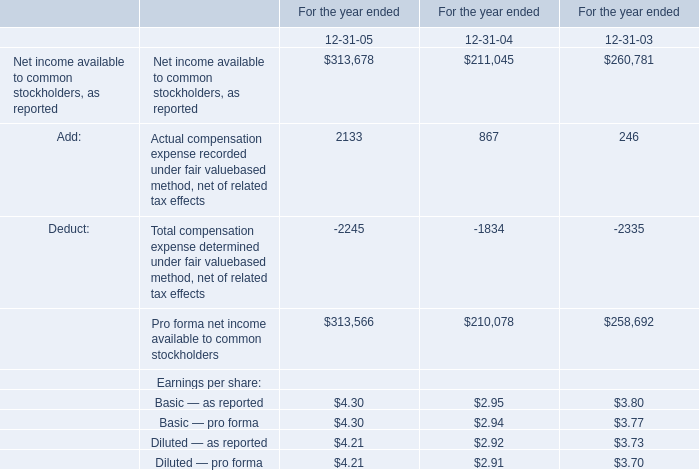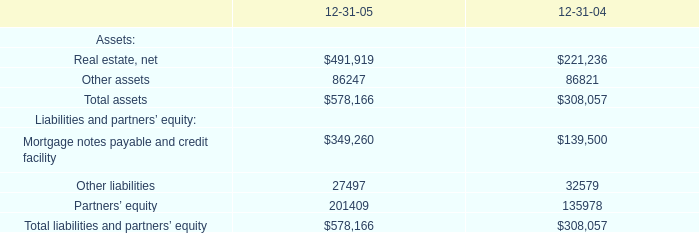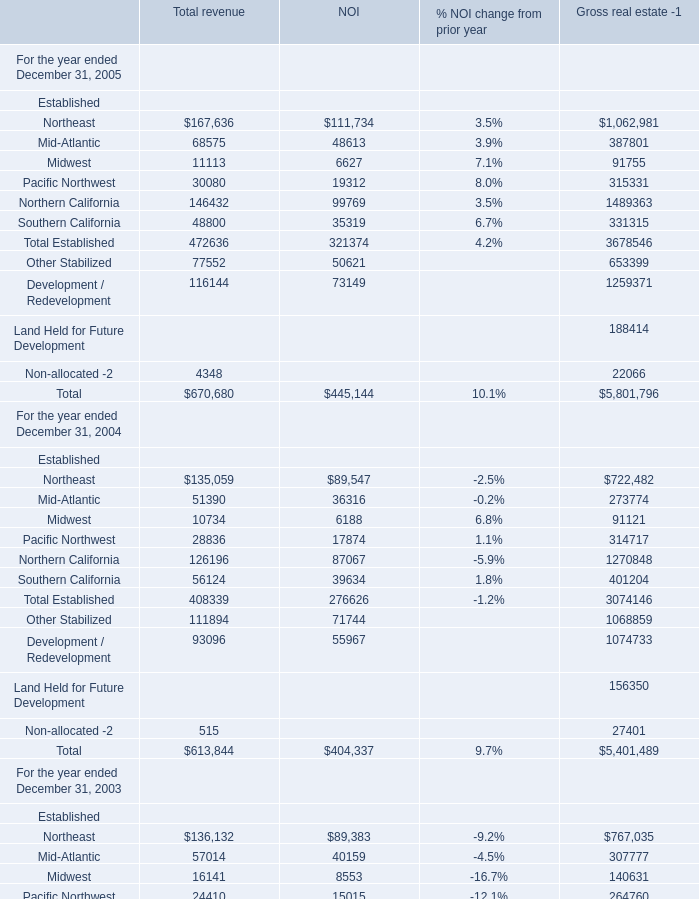What is the proportion of Midwest to the total in 2005? 
Computations: (11113 / 472636)
Answer: 0.02351. 